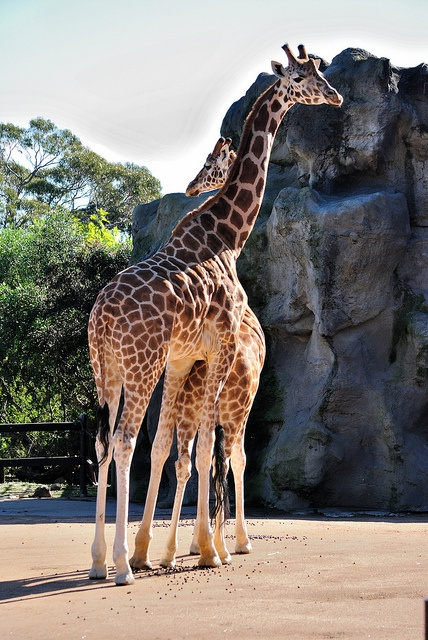Describe the objects in this image and their specific colors. I can see giraffe in lightblue, black, tan, maroon, and gray tones and giraffe in lightblue, black, ivory, and tan tones in this image. 